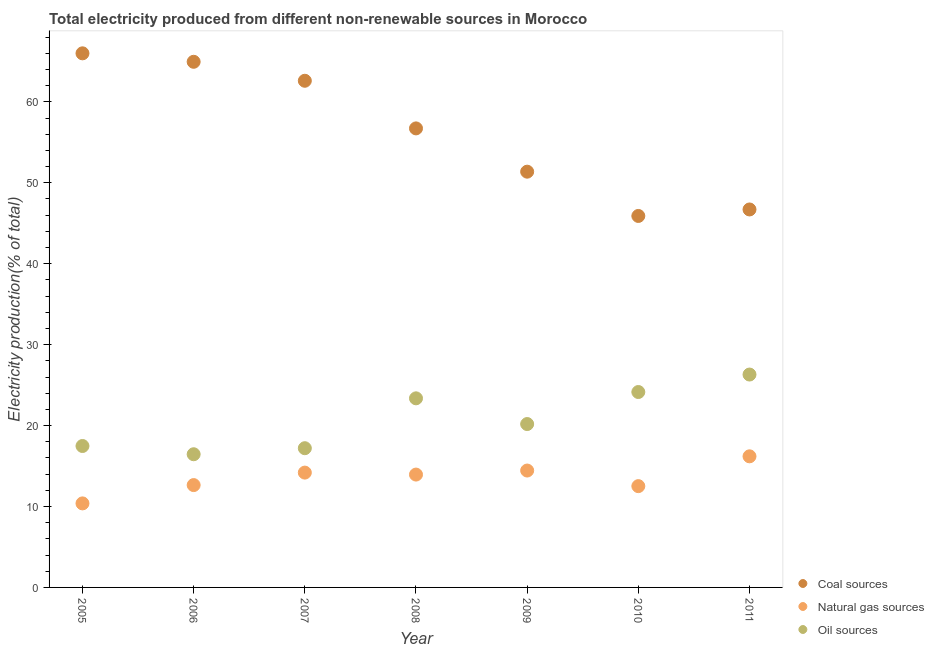What is the percentage of electricity produced by oil sources in 2007?
Offer a very short reply. 17.2. Across all years, what is the maximum percentage of electricity produced by coal?
Your answer should be compact. 66. Across all years, what is the minimum percentage of electricity produced by oil sources?
Keep it short and to the point. 16.46. What is the total percentage of electricity produced by oil sources in the graph?
Ensure brevity in your answer.  145.14. What is the difference between the percentage of electricity produced by coal in 2005 and that in 2009?
Give a very brief answer. 14.62. What is the difference between the percentage of electricity produced by coal in 2005 and the percentage of electricity produced by oil sources in 2008?
Ensure brevity in your answer.  42.63. What is the average percentage of electricity produced by natural gas per year?
Give a very brief answer. 13.47. In the year 2009, what is the difference between the percentage of electricity produced by oil sources and percentage of electricity produced by natural gas?
Offer a terse response. 5.75. What is the ratio of the percentage of electricity produced by oil sources in 2005 to that in 2008?
Make the answer very short. 0.75. Is the percentage of electricity produced by coal in 2007 less than that in 2008?
Give a very brief answer. No. What is the difference between the highest and the second highest percentage of electricity produced by natural gas?
Your response must be concise. 1.76. What is the difference between the highest and the lowest percentage of electricity produced by natural gas?
Offer a very short reply. 5.82. In how many years, is the percentage of electricity produced by coal greater than the average percentage of electricity produced by coal taken over all years?
Provide a short and direct response. 4. Is it the case that in every year, the sum of the percentage of electricity produced by coal and percentage of electricity produced by natural gas is greater than the percentage of electricity produced by oil sources?
Give a very brief answer. Yes. Does the percentage of electricity produced by oil sources monotonically increase over the years?
Provide a succinct answer. No. How many dotlines are there?
Provide a short and direct response. 3. How many years are there in the graph?
Ensure brevity in your answer.  7. What is the difference between two consecutive major ticks on the Y-axis?
Your answer should be very brief. 10. Does the graph contain any zero values?
Ensure brevity in your answer.  No. How many legend labels are there?
Provide a succinct answer. 3. How are the legend labels stacked?
Keep it short and to the point. Vertical. What is the title of the graph?
Make the answer very short. Total electricity produced from different non-renewable sources in Morocco. What is the label or title of the X-axis?
Make the answer very short. Year. What is the label or title of the Y-axis?
Your response must be concise. Electricity production(% of total). What is the Electricity production(% of total) of Coal sources in 2005?
Provide a short and direct response. 66. What is the Electricity production(% of total) in Natural gas sources in 2005?
Ensure brevity in your answer.  10.38. What is the Electricity production(% of total) of Oil sources in 2005?
Offer a very short reply. 17.48. What is the Electricity production(% of total) of Coal sources in 2006?
Keep it short and to the point. 64.95. What is the Electricity production(% of total) of Natural gas sources in 2006?
Your answer should be very brief. 12.65. What is the Electricity production(% of total) of Oil sources in 2006?
Give a very brief answer. 16.46. What is the Electricity production(% of total) in Coal sources in 2007?
Keep it short and to the point. 62.61. What is the Electricity production(% of total) of Natural gas sources in 2007?
Provide a short and direct response. 14.19. What is the Electricity production(% of total) in Oil sources in 2007?
Provide a succinct answer. 17.2. What is the Electricity production(% of total) in Coal sources in 2008?
Your answer should be compact. 56.72. What is the Electricity production(% of total) in Natural gas sources in 2008?
Your answer should be very brief. 13.94. What is the Electricity production(% of total) in Oil sources in 2008?
Give a very brief answer. 23.37. What is the Electricity production(% of total) of Coal sources in 2009?
Provide a succinct answer. 51.37. What is the Electricity production(% of total) of Natural gas sources in 2009?
Provide a succinct answer. 14.44. What is the Electricity production(% of total) of Oil sources in 2009?
Offer a terse response. 20.19. What is the Electricity production(% of total) in Coal sources in 2010?
Give a very brief answer. 45.9. What is the Electricity production(% of total) of Natural gas sources in 2010?
Provide a succinct answer. 12.52. What is the Electricity production(% of total) of Oil sources in 2010?
Ensure brevity in your answer.  24.15. What is the Electricity production(% of total) of Coal sources in 2011?
Provide a succinct answer. 46.7. What is the Electricity production(% of total) in Natural gas sources in 2011?
Provide a short and direct response. 16.2. What is the Electricity production(% of total) in Oil sources in 2011?
Offer a terse response. 26.31. Across all years, what is the maximum Electricity production(% of total) in Coal sources?
Offer a very short reply. 66. Across all years, what is the maximum Electricity production(% of total) of Natural gas sources?
Make the answer very short. 16.2. Across all years, what is the maximum Electricity production(% of total) in Oil sources?
Give a very brief answer. 26.31. Across all years, what is the minimum Electricity production(% of total) of Coal sources?
Offer a terse response. 45.9. Across all years, what is the minimum Electricity production(% of total) in Natural gas sources?
Keep it short and to the point. 10.38. Across all years, what is the minimum Electricity production(% of total) in Oil sources?
Your answer should be very brief. 16.46. What is the total Electricity production(% of total) in Coal sources in the graph?
Keep it short and to the point. 394.26. What is the total Electricity production(% of total) in Natural gas sources in the graph?
Provide a succinct answer. 94.32. What is the total Electricity production(% of total) of Oil sources in the graph?
Provide a short and direct response. 145.14. What is the difference between the Electricity production(% of total) of Coal sources in 2005 and that in 2006?
Offer a terse response. 1.05. What is the difference between the Electricity production(% of total) of Natural gas sources in 2005 and that in 2006?
Offer a terse response. -2.26. What is the difference between the Electricity production(% of total) of Oil sources in 2005 and that in 2006?
Your answer should be very brief. 1.02. What is the difference between the Electricity production(% of total) in Coal sources in 2005 and that in 2007?
Provide a short and direct response. 3.39. What is the difference between the Electricity production(% of total) in Natural gas sources in 2005 and that in 2007?
Provide a succinct answer. -3.8. What is the difference between the Electricity production(% of total) in Oil sources in 2005 and that in 2007?
Your answer should be compact. 0.27. What is the difference between the Electricity production(% of total) in Coal sources in 2005 and that in 2008?
Offer a terse response. 9.28. What is the difference between the Electricity production(% of total) of Natural gas sources in 2005 and that in 2008?
Give a very brief answer. -3.56. What is the difference between the Electricity production(% of total) in Oil sources in 2005 and that in 2008?
Your answer should be compact. -5.89. What is the difference between the Electricity production(% of total) in Coal sources in 2005 and that in 2009?
Make the answer very short. 14.62. What is the difference between the Electricity production(% of total) in Natural gas sources in 2005 and that in 2009?
Keep it short and to the point. -4.06. What is the difference between the Electricity production(% of total) in Oil sources in 2005 and that in 2009?
Keep it short and to the point. -2.71. What is the difference between the Electricity production(% of total) of Coal sources in 2005 and that in 2010?
Give a very brief answer. 20.1. What is the difference between the Electricity production(% of total) of Natural gas sources in 2005 and that in 2010?
Offer a terse response. -2.13. What is the difference between the Electricity production(% of total) in Oil sources in 2005 and that in 2010?
Keep it short and to the point. -6.67. What is the difference between the Electricity production(% of total) of Coal sources in 2005 and that in 2011?
Your answer should be compact. 19.29. What is the difference between the Electricity production(% of total) of Natural gas sources in 2005 and that in 2011?
Provide a succinct answer. -5.82. What is the difference between the Electricity production(% of total) of Oil sources in 2005 and that in 2011?
Your answer should be compact. -8.83. What is the difference between the Electricity production(% of total) of Coal sources in 2006 and that in 2007?
Provide a short and direct response. 2.34. What is the difference between the Electricity production(% of total) in Natural gas sources in 2006 and that in 2007?
Your answer should be compact. -1.54. What is the difference between the Electricity production(% of total) of Oil sources in 2006 and that in 2007?
Offer a terse response. -0.75. What is the difference between the Electricity production(% of total) of Coal sources in 2006 and that in 2008?
Keep it short and to the point. 8.23. What is the difference between the Electricity production(% of total) in Natural gas sources in 2006 and that in 2008?
Provide a succinct answer. -1.3. What is the difference between the Electricity production(% of total) in Oil sources in 2006 and that in 2008?
Offer a very short reply. -6.91. What is the difference between the Electricity production(% of total) of Coal sources in 2006 and that in 2009?
Make the answer very short. 13.58. What is the difference between the Electricity production(% of total) in Natural gas sources in 2006 and that in 2009?
Provide a short and direct response. -1.8. What is the difference between the Electricity production(% of total) of Oil sources in 2006 and that in 2009?
Provide a short and direct response. -3.73. What is the difference between the Electricity production(% of total) in Coal sources in 2006 and that in 2010?
Provide a short and direct response. 19.05. What is the difference between the Electricity production(% of total) in Natural gas sources in 2006 and that in 2010?
Provide a short and direct response. 0.13. What is the difference between the Electricity production(% of total) of Oil sources in 2006 and that in 2010?
Provide a short and direct response. -7.69. What is the difference between the Electricity production(% of total) of Coal sources in 2006 and that in 2011?
Ensure brevity in your answer.  18.25. What is the difference between the Electricity production(% of total) of Natural gas sources in 2006 and that in 2011?
Your answer should be compact. -3.55. What is the difference between the Electricity production(% of total) in Oil sources in 2006 and that in 2011?
Offer a terse response. -9.85. What is the difference between the Electricity production(% of total) in Coal sources in 2007 and that in 2008?
Provide a succinct answer. 5.89. What is the difference between the Electricity production(% of total) in Natural gas sources in 2007 and that in 2008?
Keep it short and to the point. 0.24. What is the difference between the Electricity production(% of total) in Oil sources in 2007 and that in 2008?
Provide a short and direct response. -6.16. What is the difference between the Electricity production(% of total) in Coal sources in 2007 and that in 2009?
Your response must be concise. 11.23. What is the difference between the Electricity production(% of total) of Natural gas sources in 2007 and that in 2009?
Give a very brief answer. -0.26. What is the difference between the Electricity production(% of total) in Oil sources in 2007 and that in 2009?
Provide a succinct answer. -2.99. What is the difference between the Electricity production(% of total) of Coal sources in 2007 and that in 2010?
Provide a succinct answer. 16.71. What is the difference between the Electricity production(% of total) of Natural gas sources in 2007 and that in 2010?
Keep it short and to the point. 1.67. What is the difference between the Electricity production(% of total) in Oil sources in 2007 and that in 2010?
Your response must be concise. -6.94. What is the difference between the Electricity production(% of total) in Coal sources in 2007 and that in 2011?
Your response must be concise. 15.9. What is the difference between the Electricity production(% of total) in Natural gas sources in 2007 and that in 2011?
Offer a very short reply. -2.01. What is the difference between the Electricity production(% of total) in Oil sources in 2007 and that in 2011?
Your answer should be very brief. -9.1. What is the difference between the Electricity production(% of total) of Coal sources in 2008 and that in 2009?
Offer a very short reply. 5.35. What is the difference between the Electricity production(% of total) of Natural gas sources in 2008 and that in 2009?
Provide a short and direct response. -0.5. What is the difference between the Electricity production(% of total) of Oil sources in 2008 and that in 2009?
Your answer should be very brief. 3.18. What is the difference between the Electricity production(% of total) of Coal sources in 2008 and that in 2010?
Your response must be concise. 10.82. What is the difference between the Electricity production(% of total) in Natural gas sources in 2008 and that in 2010?
Your answer should be very brief. 1.43. What is the difference between the Electricity production(% of total) of Oil sources in 2008 and that in 2010?
Your response must be concise. -0.78. What is the difference between the Electricity production(% of total) of Coal sources in 2008 and that in 2011?
Your answer should be very brief. 10.02. What is the difference between the Electricity production(% of total) in Natural gas sources in 2008 and that in 2011?
Offer a terse response. -2.26. What is the difference between the Electricity production(% of total) in Oil sources in 2008 and that in 2011?
Keep it short and to the point. -2.94. What is the difference between the Electricity production(% of total) in Coal sources in 2009 and that in 2010?
Make the answer very short. 5.47. What is the difference between the Electricity production(% of total) in Natural gas sources in 2009 and that in 2010?
Give a very brief answer. 1.93. What is the difference between the Electricity production(% of total) of Oil sources in 2009 and that in 2010?
Make the answer very short. -3.96. What is the difference between the Electricity production(% of total) in Coal sources in 2009 and that in 2011?
Your answer should be very brief. 4.67. What is the difference between the Electricity production(% of total) of Natural gas sources in 2009 and that in 2011?
Offer a very short reply. -1.76. What is the difference between the Electricity production(% of total) in Oil sources in 2009 and that in 2011?
Your answer should be compact. -6.12. What is the difference between the Electricity production(% of total) of Coal sources in 2010 and that in 2011?
Offer a very short reply. -0.8. What is the difference between the Electricity production(% of total) in Natural gas sources in 2010 and that in 2011?
Offer a terse response. -3.68. What is the difference between the Electricity production(% of total) in Oil sources in 2010 and that in 2011?
Provide a short and direct response. -2.16. What is the difference between the Electricity production(% of total) in Coal sources in 2005 and the Electricity production(% of total) in Natural gas sources in 2006?
Your answer should be compact. 53.35. What is the difference between the Electricity production(% of total) in Coal sources in 2005 and the Electricity production(% of total) in Oil sources in 2006?
Keep it short and to the point. 49.54. What is the difference between the Electricity production(% of total) in Natural gas sources in 2005 and the Electricity production(% of total) in Oil sources in 2006?
Provide a succinct answer. -6.07. What is the difference between the Electricity production(% of total) of Coal sources in 2005 and the Electricity production(% of total) of Natural gas sources in 2007?
Provide a succinct answer. 51.81. What is the difference between the Electricity production(% of total) in Coal sources in 2005 and the Electricity production(% of total) in Oil sources in 2007?
Your response must be concise. 48.79. What is the difference between the Electricity production(% of total) of Natural gas sources in 2005 and the Electricity production(% of total) of Oil sources in 2007?
Offer a very short reply. -6.82. What is the difference between the Electricity production(% of total) of Coal sources in 2005 and the Electricity production(% of total) of Natural gas sources in 2008?
Provide a short and direct response. 52.05. What is the difference between the Electricity production(% of total) in Coal sources in 2005 and the Electricity production(% of total) in Oil sources in 2008?
Offer a terse response. 42.63. What is the difference between the Electricity production(% of total) in Natural gas sources in 2005 and the Electricity production(% of total) in Oil sources in 2008?
Provide a short and direct response. -12.98. What is the difference between the Electricity production(% of total) in Coal sources in 2005 and the Electricity production(% of total) in Natural gas sources in 2009?
Keep it short and to the point. 51.55. What is the difference between the Electricity production(% of total) in Coal sources in 2005 and the Electricity production(% of total) in Oil sources in 2009?
Offer a very short reply. 45.81. What is the difference between the Electricity production(% of total) in Natural gas sources in 2005 and the Electricity production(% of total) in Oil sources in 2009?
Make the answer very short. -9.81. What is the difference between the Electricity production(% of total) in Coal sources in 2005 and the Electricity production(% of total) in Natural gas sources in 2010?
Your answer should be very brief. 53.48. What is the difference between the Electricity production(% of total) in Coal sources in 2005 and the Electricity production(% of total) in Oil sources in 2010?
Provide a short and direct response. 41.85. What is the difference between the Electricity production(% of total) of Natural gas sources in 2005 and the Electricity production(% of total) of Oil sources in 2010?
Your answer should be very brief. -13.76. What is the difference between the Electricity production(% of total) in Coal sources in 2005 and the Electricity production(% of total) in Natural gas sources in 2011?
Your answer should be compact. 49.8. What is the difference between the Electricity production(% of total) of Coal sources in 2005 and the Electricity production(% of total) of Oil sources in 2011?
Ensure brevity in your answer.  39.69. What is the difference between the Electricity production(% of total) in Natural gas sources in 2005 and the Electricity production(% of total) in Oil sources in 2011?
Offer a terse response. -15.92. What is the difference between the Electricity production(% of total) in Coal sources in 2006 and the Electricity production(% of total) in Natural gas sources in 2007?
Provide a short and direct response. 50.76. What is the difference between the Electricity production(% of total) of Coal sources in 2006 and the Electricity production(% of total) of Oil sources in 2007?
Keep it short and to the point. 47.75. What is the difference between the Electricity production(% of total) in Natural gas sources in 2006 and the Electricity production(% of total) in Oil sources in 2007?
Offer a very short reply. -4.56. What is the difference between the Electricity production(% of total) in Coal sources in 2006 and the Electricity production(% of total) in Natural gas sources in 2008?
Provide a succinct answer. 51.01. What is the difference between the Electricity production(% of total) in Coal sources in 2006 and the Electricity production(% of total) in Oil sources in 2008?
Offer a very short reply. 41.59. What is the difference between the Electricity production(% of total) in Natural gas sources in 2006 and the Electricity production(% of total) in Oil sources in 2008?
Offer a terse response. -10.72. What is the difference between the Electricity production(% of total) in Coal sources in 2006 and the Electricity production(% of total) in Natural gas sources in 2009?
Make the answer very short. 50.51. What is the difference between the Electricity production(% of total) of Coal sources in 2006 and the Electricity production(% of total) of Oil sources in 2009?
Your response must be concise. 44.76. What is the difference between the Electricity production(% of total) of Natural gas sources in 2006 and the Electricity production(% of total) of Oil sources in 2009?
Make the answer very short. -7.54. What is the difference between the Electricity production(% of total) of Coal sources in 2006 and the Electricity production(% of total) of Natural gas sources in 2010?
Make the answer very short. 52.43. What is the difference between the Electricity production(% of total) in Coal sources in 2006 and the Electricity production(% of total) in Oil sources in 2010?
Offer a terse response. 40.8. What is the difference between the Electricity production(% of total) in Natural gas sources in 2006 and the Electricity production(% of total) in Oil sources in 2010?
Your answer should be compact. -11.5. What is the difference between the Electricity production(% of total) in Coal sources in 2006 and the Electricity production(% of total) in Natural gas sources in 2011?
Ensure brevity in your answer.  48.75. What is the difference between the Electricity production(% of total) in Coal sources in 2006 and the Electricity production(% of total) in Oil sources in 2011?
Your response must be concise. 38.65. What is the difference between the Electricity production(% of total) of Natural gas sources in 2006 and the Electricity production(% of total) of Oil sources in 2011?
Your answer should be very brief. -13.66. What is the difference between the Electricity production(% of total) in Coal sources in 2007 and the Electricity production(% of total) in Natural gas sources in 2008?
Provide a succinct answer. 48.66. What is the difference between the Electricity production(% of total) in Coal sources in 2007 and the Electricity production(% of total) in Oil sources in 2008?
Keep it short and to the point. 39.24. What is the difference between the Electricity production(% of total) of Natural gas sources in 2007 and the Electricity production(% of total) of Oil sources in 2008?
Keep it short and to the point. -9.18. What is the difference between the Electricity production(% of total) of Coal sources in 2007 and the Electricity production(% of total) of Natural gas sources in 2009?
Your response must be concise. 48.16. What is the difference between the Electricity production(% of total) of Coal sources in 2007 and the Electricity production(% of total) of Oil sources in 2009?
Ensure brevity in your answer.  42.42. What is the difference between the Electricity production(% of total) in Natural gas sources in 2007 and the Electricity production(% of total) in Oil sources in 2009?
Make the answer very short. -6. What is the difference between the Electricity production(% of total) in Coal sources in 2007 and the Electricity production(% of total) in Natural gas sources in 2010?
Offer a very short reply. 50.09. What is the difference between the Electricity production(% of total) in Coal sources in 2007 and the Electricity production(% of total) in Oil sources in 2010?
Your response must be concise. 38.46. What is the difference between the Electricity production(% of total) in Natural gas sources in 2007 and the Electricity production(% of total) in Oil sources in 2010?
Your answer should be compact. -9.96. What is the difference between the Electricity production(% of total) of Coal sources in 2007 and the Electricity production(% of total) of Natural gas sources in 2011?
Give a very brief answer. 46.41. What is the difference between the Electricity production(% of total) of Coal sources in 2007 and the Electricity production(% of total) of Oil sources in 2011?
Your response must be concise. 36.3. What is the difference between the Electricity production(% of total) of Natural gas sources in 2007 and the Electricity production(% of total) of Oil sources in 2011?
Your answer should be compact. -12.12. What is the difference between the Electricity production(% of total) in Coal sources in 2008 and the Electricity production(% of total) in Natural gas sources in 2009?
Provide a short and direct response. 42.28. What is the difference between the Electricity production(% of total) of Coal sources in 2008 and the Electricity production(% of total) of Oil sources in 2009?
Offer a terse response. 36.53. What is the difference between the Electricity production(% of total) in Natural gas sources in 2008 and the Electricity production(% of total) in Oil sources in 2009?
Provide a short and direct response. -6.24. What is the difference between the Electricity production(% of total) of Coal sources in 2008 and the Electricity production(% of total) of Natural gas sources in 2010?
Your answer should be very brief. 44.2. What is the difference between the Electricity production(% of total) in Coal sources in 2008 and the Electricity production(% of total) in Oil sources in 2010?
Make the answer very short. 32.58. What is the difference between the Electricity production(% of total) in Natural gas sources in 2008 and the Electricity production(% of total) in Oil sources in 2010?
Your answer should be compact. -10.2. What is the difference between the Electricity production(% of total) of Coal sources in 2008 and the Electricity production(% of total) of Natural gas sources in 2011?
Offer a terse response. 40.52. What is the difference between the Electricity production(% of total) in Coal sources in 2008 and the Electricity production(% of total) in Oil sources in 2011?
Provide a short and direct response. 30.42. What is the difference between the Electricity production(% of total) of Natural gas sources in 2008 and the Electricity production(% of total) of Oil sources in 2011?
Make the answer very short. -12.36. What is the difference between the Electricity production(% of total) in Coal sources in 2009 and the Electricity production(% of total) in Natural gas sources in 2010?
Keep it short and to the point. 38.86. What is the difference between the Electricity production(% of total) of Coal sources in 2009 and the Electricity production(% of total) of Oil sources in 2010?
Ensure brevity in your answer.  27.23. What is the difference between the Electricity production(% of total) of Natural gas sources in 2009 and the Electricity production(% of total) of Oil sources in 2010?
Make the answer very short. -9.7. What is the difference between the Electricity production(% of total) in Coal sources in 2009 and the Electricity production(% of total) in Natural gas sources in 2011?
Give a very brief answer. 35.17. What is the difference between the Electricity production(% of total) of Coal sources in 2009 and the Electricity production(% of total) of Oil sources in 2011?
Your answer should be very brief. 25.07. What is the difference between the Electricity production(% of total) of Natural gas sources in 2009 and the Electricity production(% of total) of Oil sources in 2011?
Keep it short and to the point. -11.86. What is the difference between the Electricity production(% of total) in Coal sources in 2010 and the Electricity production(% of total) in Natural gas sources in 2011?
Ensure brevity in your answer.  29.7. What is the difference between the Electricity production(% of total) in Coal sources in 2010 and the Electricity production(% of total) in Oil sources in 2011?
Give a very brief answer. 19.6. What is the difference between the Electricity production(% of total) in Natural gas sources in 2010 and the Electricity production(% of total) in Oil sources in 2011?
Your answer should be very brief. -13.79. What is the average Electricity production(% of total) in Coal sources per year?
Offer a terse response. 56.32. What is the average Electricity production(% of total) of Natural gas sources per year?
Your response must be concise. 13.47. What is the average Electricity production(% of total) in Oil sources per year?
Provide a short and direct response. 20.73. In the year 2005, what is the difference between the Electricity production(% of total) in Coal sources and Electricity production(% of total) in Natural gas sources?
Your answer should be very brief. 55.61. In the year 2005, what is the difference between the Electricity production(% of total) of Coal sources and Electricity production(% of total) of Oil sources?
Your answer should be compact. 48.52. In the year 2005, what is the difference between the Electricity production(% of total) of Natural gas sources and Electricity production(% of total) of Oil sources?
Give a very brief answer. -7.09. In the year 2006, what is the difference between the Electricity production(% of total) in Coal sources and Electricity production(% of total) in Natural gas sources?
Your response must be concise. 52.31. In the year 2006, what is the difference between the Electricity production(% of total) in Coal sources and Electricity production(% of total) in Oil sources?
Provide a succinct answer. 48.49. In the year 2006, what is the difference between the Electricity production(% of total) of Natural gas sources and Electricity production(% of total) of Oil sources?
Provide a succinct answer. -3.81. In the year 2007, what is the difference between the Electricity production(% of total) of Coal sources and Electricity production(% of total) of Natural gas sources?
Your answer should be compact. 48.42. In the year 2007, what is the difference between the Electricity production(% of total) in Coal sources and Electricity production(% of total) in Oil sources?
Your answer should be very brief. 45.4. In the year 2007, what is the difference between the Electricity production(% of total) of Natural gas sources and Electricity production(% of total) of Oil sources?
Your answer should be very brief. -3.02. In the year 2008, what is the difference between the Electricity production(% of total) of Coal sources and Electricity production(% of total) of Natural gas sources?
Give a very brief answer. 42.78. In the year 2008, what is the difference between the Electricity production(% of total) of Coal sources and Electricity production(% of total) of Oil sources?
Offer a very short reply. 33.36. In the year 2008, what is the difference between the Electricity production(% of total) in Natural gas sources and Electricity production(% of total) in Oil sources?
Your response must be concise. -9.42. In the year 2009, what is the difference between the Electricity production(% of total) in Coal sources and Electricity production(% of total) in Natural gas sources?
Your response must be concise. 36.93. In the year 2009, what is the difference between the Electricity production(% of total) in Coal sources and Electricity production(% of total) in Oil sources?
Your response must be concise. 31.18. In the year 2009, what is the difference between the Electricity production(% of total) in Natural gas sources and Electricity production(% of total) in Oil sources?
Your response must be concise. -5.75. In the year 2010, what is the difference between the Electricity production(% of total) of Coal sources and Electricity production(% of total) of Natural gas sources?
Keep it short and to the point. 33.39. In the year 2010, what is the difference between the Electricity production(% of total) in Coal sources and Electricity production(% of total) in Oil sources?
Keep it short and to the point. 21.76. In the year 2010, what is the difference between the Electricity production(% of total) of Natural gas sources and Electricity production(% of total) of Oil sources?
Your answer should be very brief. -11.63. In the year 2011, what is the difference between the Electricity production(% of total) in Coal sources and Electricity production(% of total) in Natural gas sources?
Your answer should be compact. 30.5. In the year 2011, what is the difference between the Electricity production(% of total) in Coal sources and Electricity production(% of total) in Oil sources?
Offer a very short reply. 20.4. In the year 2011, what is the difference between the Electricity production(% of total) in Natural gas sources and Electricity production(% of total) in Oil sources?
Your answer should be compact. -10.11. What is the ratio of the Electricity production(% of total) in Coal sources in 2005 to that in 2006?
Provide a succinct answer. 1.02. What is the ratio of the Electricity production(% of total) of Natural gas sources in 2005 to that in 2006?
Make the answer very short. 0.82. What is the ratio of the Electricity production(% of total) in Oil sources in 2005 to that in 2006?
Provide a short and direct response. 1.06. What is the ratio of the Electricity production(% of total) of Coal sources in 2005 to that in 2007?
Provide a short and direct response. 1.05. What is the ratio of the Electricity production(% of total) in Natural gas sources in 2005 to that in 2007?
Make the answer very short. 0.73. What is the ratio of the Electricity production(% of total) in Oil sources in 2005 to that in 2007?
Offer a terse response. 1.02. What is the ratio of the Electricity production(% of total) of Coal sources in 2005 to that in 2008?
Your response must be concise. 1.16. What is the ratio of the Electricity production(% of total) of Natural gas sources in 2005 to that in 2008?
Provide a short and direct response. 0.74. What is the ratio of the Electricity production(% of total) of Oil sources in 2005 to that in 2008?
Your response must be concise. 0.75. What is the ratio of the Electricity production(% of total) of Coal sources in 2005 to that in 2009?
Offer a terse response. 1.28. What is the ratio of the Electricity production(% of total) in Natural gas sources in 2005 to that in 2009?
Your answer should be compact. 0.72. What is the ratio of the Electricity production(% of total) in Oil sources in 2005 to that in 2009?
Keep it short and to the point. 0.87. What is the ratio of the Electricity production(% of total) of Coal sources in 2005 to that in 2010?
Your answer should be very brief. 1.44. What is the ratio of the Electricity production(% of total) of Natural gas sources in 2005 to that in 2010?
Provide a succinct answer. 0.83. What is the ratio of the Electricity production(% of total) of Oil sources in 2005 to that in 2010?
Make the answer very short. 0.72. What is the ratio of the Electricity production(% of total) of Coal sources in 2005 to that in 2011?
Your answer should be very brief. 1.41. What is the ratio of the Electricity production(% of total) in Natural gas sources in 2005 to that in 2011?
Your answer should be very brief. 0.64. What is the ratio of the Electricity production(% of total) in Oil sources in 2005 to that in 2011?
Your answer should be compact. 0.66. What is the ratio of the Electricity production(% of total) in Coal sources in 2006 to that in 2007?
Keep it short and to the point. 1.04. What is the ratio of the Electricity production(% of total) in Natural gas sources in 2006 to that in 2007?
Make the answer very short. 0.89. What is the ratio of the Electricity production(% of total) in Oil sources in 2006 to that in 2007?
Give a very brief answer. 0.96. What is the ratio of the Electricity production(% of total) in Coal sources in 2006 to that in 2008?
Your response must be concise. 1.15. What is the ratio of the Electricity production(% of total) in Natural gas sources in 2006 to that in 2008?
Make the answer very short. 0.91. What is the ratio of the Electricity production(% of total) of Oil sources in 2006 to that in 2008?
Ensure brevity in your answer.  0.7. What is the ratio of the Electricity production(% of total) of Coal sources in 2006 to that in 2009?
Provide a short and direct response. 1.26. What is the ratio of the Electricity production(% of total) of Natural gas sources in 2006 to that in 2009?
Provide a succinct answer. 0.88. What is the ratio of the Electricity production(% of total) in Oil sources in 2006 to that in 2009?
Your answer should be very brief. 0.82. What is the ratio of the Electricity production(% of total) in Coal sources in 2006 to that in 2010?
Your answer should be very brief. 1.42. What is the ratio of the Electricity production(% of total) in Natural gas sources in 2006 to that in 2010?
Keep it short and to the point. 1.01. What is the ratio of the Electricity production(% of total) of Oil sources in 2006 to that in 2010?
Your response must be concise. 0.68. What is the ratio of the Electricity production(% of total) in Coal sources in 2006 to that in 2011?
Provide a succinct answer. 1.39. What is the ratio of the Electricity production(% of total) in Natural gas sources in 2006 to that in 2011?
Your answer should be very brief. 0.78. What is the ratio of the Electricity production(% of total) of Oil sources in 2006 to that in 2011?
Provide a short and direct response. 0.63. What is the ratio of the Electricity production(% of total) in Coal sources in 2007 to that in 2008?
Provide a succinct answer. 1.1. What is the ratio of the Electricity production(% of total) in Natural gas sources in 2007 to that in 2008?
Offer a terse response. 1.02. What is the ratio of the Electricity production(% of total) of Oil sources in 2007 to that in 2008?
Offer a terse response. 0.74. What is the ratio of the Electricity production(% of total) in Coal sources in 2007 to that in 2009?
Your answer should be very brief. 1.22. What is the ratio of the Electricity production(% of total) of Natural gas sources in 2007 to that in 2009?
Your response must be concise. 0.98. What is the ratio of the Electricity production(% of total) of Oil sources in 2007 to that in 2009?
Provide a succinct answer. 0.85. What is the ratio of the Electricity production(% of total) in Coal sources in 2007 to that in 2010?
Your response must be concise. 1.36. What is the ratio of the Electricity production(% of total) of Natural gas sources in 2007 to that in 2010?
Provide a short and direct response. 1.13. What is the ratio of the Electricity production(% of total) of Oil sources in 2007 to that in 2010?
Provide a succinct answer. 0.71. What is the ratio of the Electricity production(% of total) in Coal sources in 2007 to that in 2011?
Make the answer very short. 1.34. What is the ratio of the Electricity production(% of total) in Natural gas sources in 2007 to that in 2011?
Provide a short and direct response. 0.88. What is the ratio of the Electricity production(% of total) of Oil sources in 2007 to that in 2011?
Offer a terse response. 0.65. What is the ratio of the Electricity production(% of total) of Coal sources in 2008 to that in 2009?
Provide a short and direct response. 1.1. What is the ratio of the Electricity production(% of total) in Natural gas sources in 2008 to that in 2009?
Your answer should be very brief. 0.97. What is the ratio of the Electricity production(% of total) of Oil sources in 2008 to that in 2009?
Give a very brief answer. 1.16. What is the ratio of the Electricity production(% of total) in Coal sources in 2008 to that in 2010?
Offer a very short reply. 1.24. What is the ratio of the Electricity production(% of total) in Natural gas sources in 2008 to that in 2010?
Your response must be concise. 1.11. What is the ratio of the Electricity production(% of total) in Coal sources in 2008 to that in 2011?
Offer a terse response. 1.21. What is the ratio of the Electricity production(% of total) in Natural gas sources in 2008 to that in 2011?
Offer a very short reply. 0.86. What is the ratio of the Electricity production(% of total) of Oil sources in 2008 to that in 2011?
Your answer should be very brief. 0.89. What is the ratio of the Electricity production(% of total) of Coal sources in 2009 to that in 2010?
Keep it short and to the point. 1.12. What is the ratio of the Electricity production(% of total) of Natural gas sources in 2009 to that in 2010?
Give a very brief answer. 1.15. What is the ratio of the Electricity production(% of total) of Oil sources in 2009 to that in 2010?
Ensure brevity in your answer.  0.84. What is the ratio of the Electricity production(% of total) in Natural gas sources in 2009 to that in 2011?
Keep it short and to the point. 0.89. What is the ratio of the Electricity production(% of total) in Oil sources in 2009 to that in 2011?
Keep it short and to the point. 0.77. What is the ratio of the Electricity production(% of total) in Coal sources in 2010 to that in 2011?
Offer a terse response. 0.98. What is the ratio of the Electricity production(% of total) in Natural gas sources in 2010 to that in 2011?
Provide a succinct answer. 0.77. What is the ratio of the Electricity production(% of total) of Oil sources in 2010 to that in 2011?
Keep it short and to the point. 0.92. What is the difference between the highest and the second highest Electricity production(% of total) of Coal sources?
Ensure brevity in your answer.  1.05. What is the difference between the highest and the second highest Electricity production(% of total) in Natural gas sources?
Give a very brief answer. 1.76. What is the difference between the highest and the second highest Electricity production(% of total) in Oil sources?
Your answer should be very brief. 2.16. What is the difference between the highest and the lowest Electricity production(% of total) of Coal sources?
Give a very brief answer. 20.1. What is the difference between the highest and the lowest Electricity production(% of total) of Natural gas sources?
Give a very brief answer. 5.82. What is the difference between the highest and the lowest Electricity production(% of total) in Oil sources?
Your answer should be compact. 9.85. 